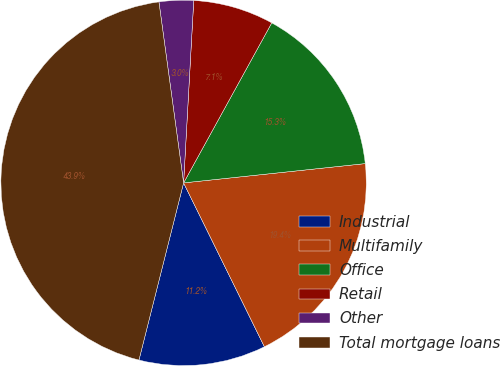Convert chart. <chart><loc_0><loc_0><loc_500><loc_500><pie_chart><fcel>Industrial<fcel>Multifamily<fcel>Office<fcel>Retail<fcel>Other<fcel>Total mortgage loans<nl><fcel>11.22%<fcel>19.39%<fcel>15.3%<fcel>7.13%<fcel>3.04%<fcel>43.91%<nl></chart> 